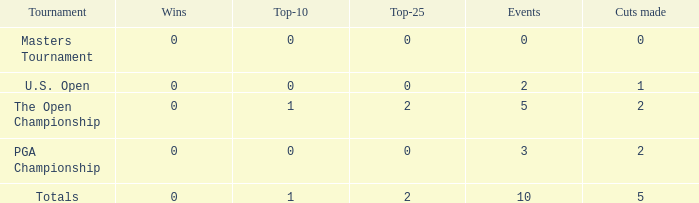What is the total number of cuts made for events played more than 3 times and under 2 top-25s? 0.0. 